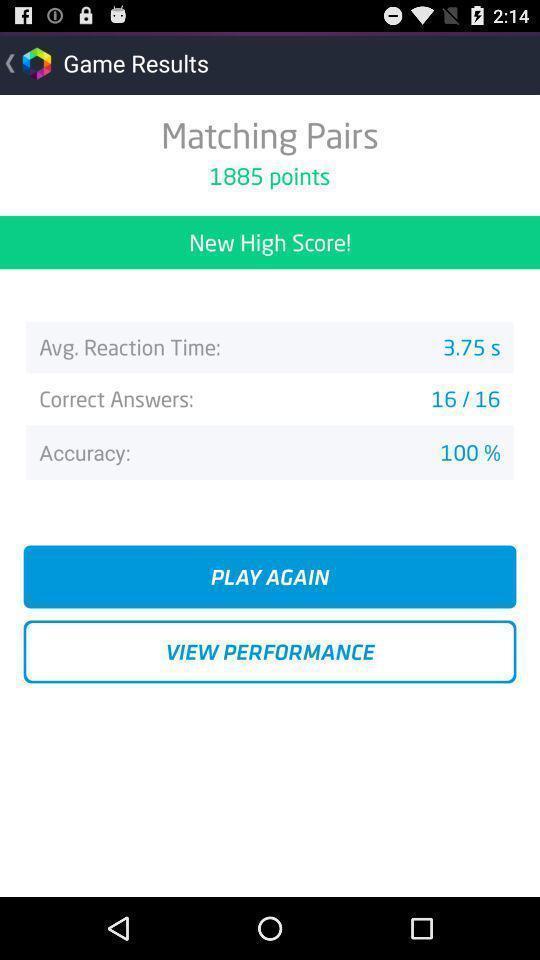Explain what's happening in this screen capture. Screen shows results of game. 